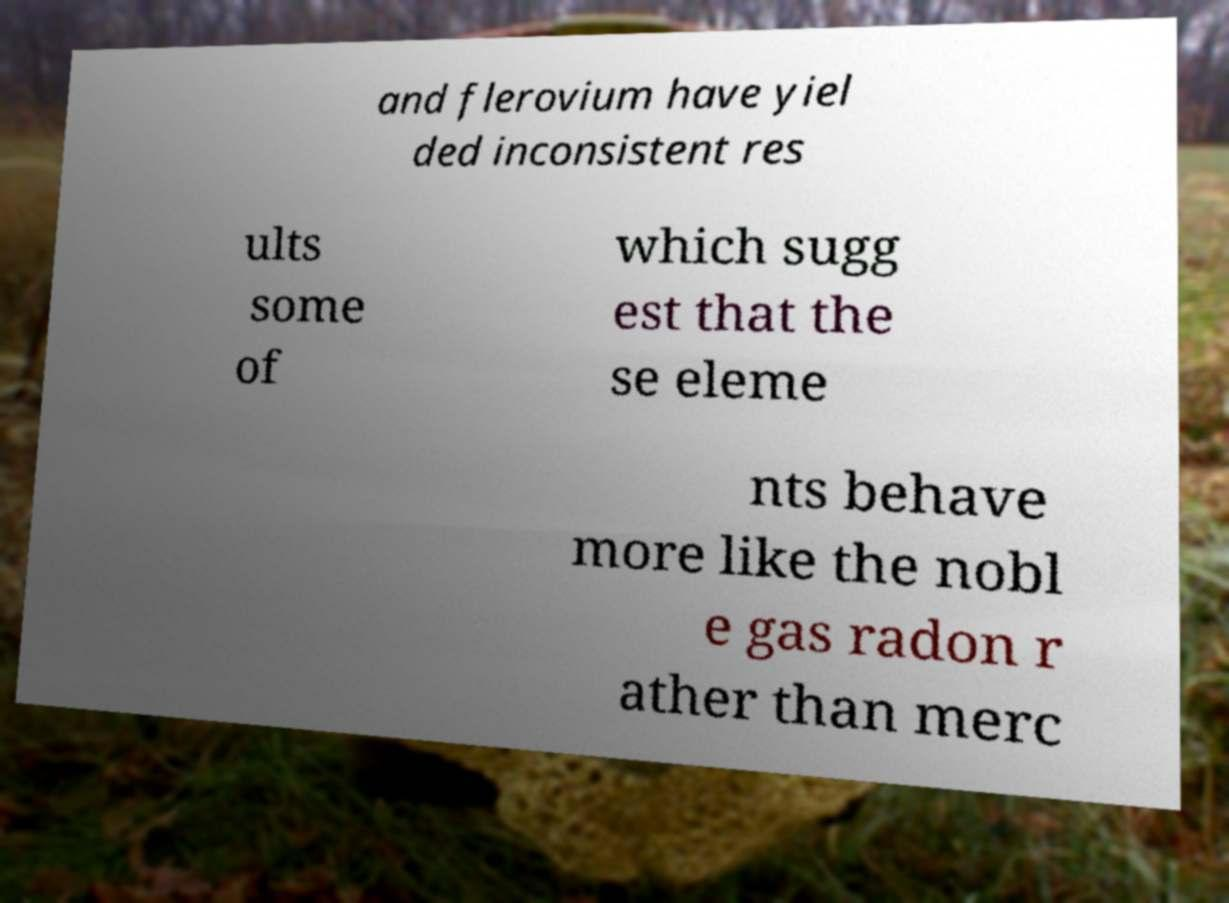Please read and relay the text visible in this image. What does it say? and flerovium have yiel ded inconsistent res ults some of which sugg est that the se eleme nts behave more like the nobl e gas radon r ather than merc 